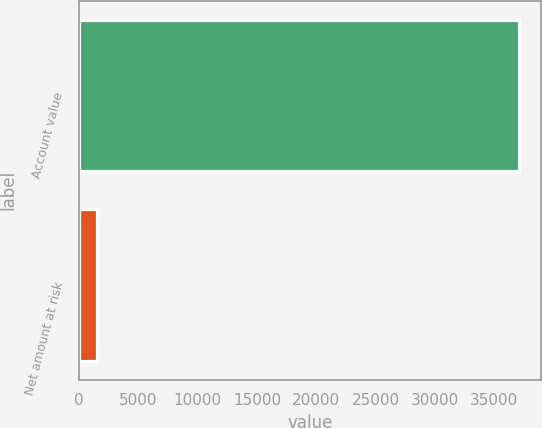<chart> <loc_0><loc_0><loc_500><loc_500><bar_chart><fcel>Account value<fcel>Net amount at risk<nl><fcel>37071<fcel>1491<nl></chart> 